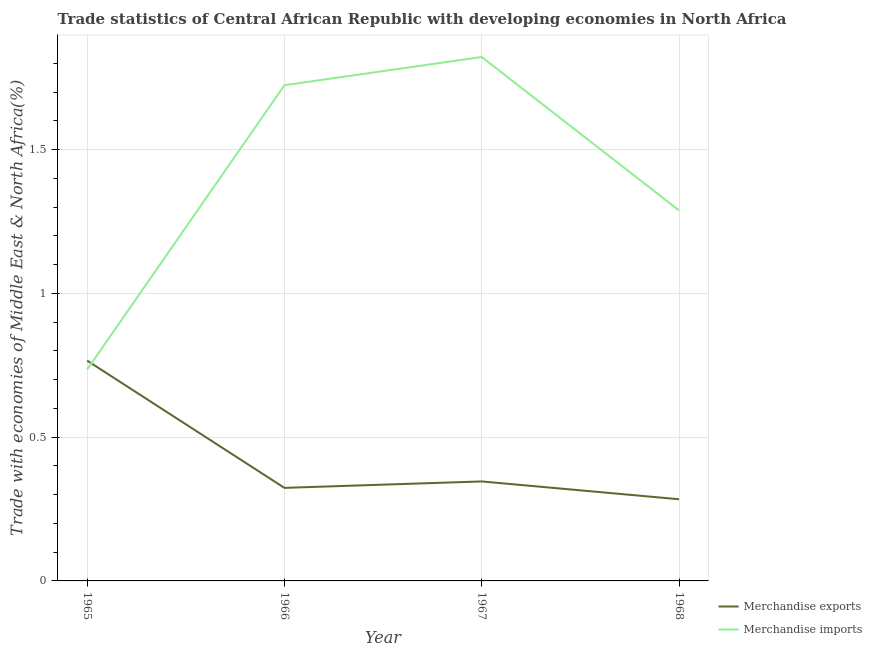What is the merchandise imports in 1965?
Give a very brief answer. 0.74. Across all years, what is the maximum merchandise imports?
Ensure brevity in your answer.  1.82. Across all years, what is the minimum merchandise exports?
Ensure brevity in your answer.  0.28. In which year was the merchandise exports maximum?
Give a very brief answer. 1965. In which year was the merchandise imports minimum?
Offer a terse response. 1965. What is the total merchandise exports in the graph?
Provide a short and direct response. 1.72. What is the difference between the merchandise imports in 1966 and that in 1968?
Give a very brief answer. 0.44. What is the difference between the merchandise exports in 1967 and the merchandise imports in 1965?
Provide a short and direct response. -0.39. What is the average merchandise imports per year?
Your answer should be compact. 1.39. In the year 1966, what is the difference between the merchandise imports and merchandise exports?
Keep it short and to the point. 1.4. What is the ratio of the merchandise imports in 1965 to that in 1966?
Offer a very short reply. 0.43. Is the merchandise imports in 1967 less than that in 1968?
Give a very brief answer. No. What is the difference between the highest and the second highest merchandise exports?
Your answer should be very brief. 0.42. What is the difference between the highest and the lowest merchandise exports?
Keep it short and to the point. 0.48. Is the merchandise exports strictly greater than the merchandise imports over the years?
Your answer should be very brief. No. How many lines are there?
Ensure brevity in your answer.  2. How many years are there in the graph?
Make the answer very short. 4. Are the values on the major ticks of Y-axis written in scientific E-notation?
Provide a succinct answer. No. Where does the legend appear in the graph?
Offer a very short reply. Bottom right. How many legend labels are there?
Ensure brevity in your answer.  2. How are the legend labels stacked?
Give a very brief answer. Vertical. What is the title of the graph?
Keep it short and to the point. Trade statistics of Central African Republic with developing economies in North Africa. Does "Domestic liabilities" appear as one of the legend labels in the graph?
Provide a short and direct response. No. What is the label or title of the X-axis?
Provide a succinct answer. Year. What is the label or title of the Y-axis?
Your response must be concise. Trade with economies of Middle East & North Africa(%). What is the Trade with economies of Middle East & North Africa(%) in Merchandise exports in 1965?
Make the answer very short. 0.77. What is the Trade with economies of Middle East & North Africa(%) in Merchandise imports in 1965?
Make the answer very short. 0.74. What is the Trade with economies of Middle East & North Africa(%) in Merchandise exports in 1966?
Offer a very short reply. 0.32. What is the Trade with economies of Middle East & North Africa(%) of Merchandise imports in 1966?
Provide a short and direct response. 1.72. What is the Trade with economies of Middle East & North Africa(%) in Merchandise exports in 1967?
Keep it short and to the point. 0.35. What is the Trade with economies of Middle East & North Africa(%) in Merchandise imports in 1967?
Keep it short and to the point. 1.82. What is the Trade with economies of Middle East & North Africa(%) in Merchandise exports in 1968?
Ensure brevity in your answer.  0.28. What is the Trade with economies of Middle East & North Africa(%) in Merchandise imports in 1968?
Make the answer very short. 1.29. Across all years, what is the maximum Trade with economies of Middle East & North Africa(%) in Merchandise exports?
Your response must be concise. 0.77. Across all years, what is the maximum Trade with economies of Middle East & North Africa(%) in Merchandise imports?
Keep it short and to the point. 1.82. Across all years, what is the minimum Trade with economies of Middle East & North Africa(%) of Merchandise exports?
Your answer should be very brief. 0.28. Across all years, what is the minimum Trade with economies of Middle East & North Africa(%) of Merchandise imports?
Offer a very short reply. 0.74. What is the total Trade with economies of Middle East & North Africa(%) in Merchandise exports in the graph?
Give a very brief answer. 1.72. What is the total Trade with economies of Middle East & North Africa(%) in Merchandise imports in the graph?
Your answer should be very brief. 5.57. What is the difference between the Trade with economies of Middle East & North Africa(%) in Merchandise exports in 1965 and that in 1966?
Your response must be concise. 0.44. What is the difference between the Trade with economies of Middle East & North Africa(%) in Merchandise imports in 1965 and that in 1966?
Offer a terse response. -0.99. What is the difference between the Trade with economies of Middle East & North Africa(%) of Merchandise exports in 1965 and that in 1967?
Give a very brief answer. 0.42. What is the difference between the Trade with economies of Middle East & North Africa(%) of Merchandise imports in 1965 and that in 1967?
Give a very brief answer. -1.09. What is the difference between the Trade with economies of Middle East & North Africa(%) of Merchandise exports in 1965 and that in 1968?
Provide a short and direct response. 0.48. What is the difference between the Trade with economies of Middle East & North Africa(%) of Merchandise imports in 1965 and that in 1968?
Ensure brevity in your answer.  -0.55. What is the difference between the Trade with economies of Middle East & North Africa(%) of Merchandise exports in 1966 and that in 1967?
Your answer should be very brief. -0.02. What is the difference between the Trade with economies of Middle East & North Africa(%) of Merchandise imports in 1966 and that in 1967?
Keep it short and to the point. -0.1. What is the difference between the Trade with economies of Middle East & North Africa(%) in Merchandise exports in 1966 and that in 1968?
Give a very brief answer. 0.04. What is the difference between the Trade with economies of Middle East & North Africa(%) in Merchandise imports in 1966 and that in 1968?
Provide a succinct answer. 0.44. What is the difference between the Trade with economies of Middle East & North Africa(%) of Merchandise exports in 1967 and that in 1968?
Provide a short and direct response. 0.06. What is the difference between the Trade with economies of Middle East & North Africa(%) in Merchandise imports in 1967 and that in 1968?
Provide a short and direct response. 0.53. What is the difference between the Trade with economies of Middle East & North Africa(%) of Merchandise exports in 1965 and the Trade with economies of Middle East & North Africa(%) of Merchandise imports in 1966?
Give a very brief answer. -0.96. What is the difference between the Trade with economies of Middle East & North Africa(%) in Merchandise exports in 1965 and the Trade with economies of Middle East & North Africa(%) in Merchandise imports in 1967?
Your answer should be very brief. -1.06. What is the difference between the Trade with economies of Middle East & North Africa(%) of Merchandise exports in 1965 and the Trade with economies of Middle East & North Africa(%) of Merchandise imports in 1968?
Provide a short and direct response. -0.52. What is the difference between the Trade with economies of Middle East & North Africa(%) of Merchandise exports in 1966 and the Trade with economies of Middle East & North Africa(%) of Merchandise imports in 1967?
Keep it short and to the point. -1.5. What is the difference between the Trade with economies of Middle East & North Africa(%) in Merchandise exports in 1966 and the Trade with economies of Middle East & North Africa(%) in Merchandise imports in 1968?
Offer a terse response. -0.96. What is the difference between the Trade with economies of Middle East & North Africa(%) of Merchandise exports in 1967 and the Trade with economies of Middle East & North Africa(%) of Merchandise imports in 1968?
Give a very brief answer. -0.94. What is the average Trade with economies of Middle East & North Africa(%) of Merchandise exports per year?
Offer a very short reply. 0.43. What is the average Trade with economies of Middle East & North Africa(%) of Merchandise imports per year?
Offer a terse response. 1.39. In the year 1965, what is the difference between the Trade with economies of Middle East & North Africa(%) of Merchandise exports and Trade with economies of Middle East & North Africa(%) of Merchandise imports?
Provide a short and direct response. 0.03. In the year 1966, what is the difference between the Trade with economies of Middle East & North Africa(%) in Merchandise exports and Trade with economies of Middle East & North Africa(%) in Merchandise imports?
Offer a very short reply. -1.4. In the year 1967, what is the difference between the Trade with economies of Middle East & North Africa(%) in Merchandise exports and Trade with economies of Middle East & North Africa(%) in Merchandise imports?
Your answer should be compact. -1.48. In the year 1968, what is the difference between the Trade with economies of Middle East & North Africa(%) of Merchandise exports and Trade with economies of Middle East & North Africa(%) of Merchandise imports?
Your answer should be compact. -1. What is the ratio of the Trade with economies of Middle East & North Africa(%) of Merchandise exports in 1965 to that in 1966?
Offer a very short reply. 2.37. What is the ratio of the Trade with economies of Middle East & North Africa(%) in Merchandise imports in 1965 to that in 1966?
Offer a very short reply. 0.43. What is the ratio of the Trade with economies of Middle East & North Africa(%) in Merchandise exports in 1965 to that in 1967?
Provide a short and direct response. 2.21. What is the ratio of the Trade with economies of Middle East & North Africa(%) of Merchandise imports in 1965 to that in 1967?
Keep it short and to the point. 0.4. What is the ratio of the Trade with economies of Middle East & North Africa(%) of Merchandise exports in 1965 to that in 1968?
Provide a succinct answer. 2.7. What is the ratio of the Trade with economies of Middle East & North Africa(%) in Merchandise imports in 1965 to that in 1968?
Make the answer very short. 0.57. What is the ratio of the Trade with economies of Middle East & North Africa(%) of Merchandise exports in 1966 to that in 1967?
Ensure brevity in your answer.  0.94. What is the ratio of the Trade with economies of Middle East & North Africa(%) in Merchandise imports in 1966 to that in 1967?
Ensure brevity in your answer.  0.95. What is the ratio of the Trade with economies of Middle East & North Africa(%) in Merchandise exports in 1966 to that in 1968?
Your response must be concise. 1.14. What is the ratio of the Trade with economies of Middle East & North Africa(%) in Merchandise imports in 1966 to that in 1968?
Provide a succinct answer. 1.34. What is the ratio of the Trade with economies of Middle East & North Africa(%) in Merchandise exports in 1967 to that in 1968?
Ensure brevity in your answer.  1.22. What is the ratio of the Trade with economies of Middle East & North Africa(%) of Merchandise imports in 1967 to that in 1968?
Provide a succinct answer. 1.41. What is the difference between the highest and the second highest Trade with economies of Middle East & North Africa(%) in Merchandise exports?
Keep it short and to the point. 0.42. What is the difference between the highest and the second highest Trade with economies of Middle East & North Africa(%) in Merchandise imports?
Provide a short and direct response. 0.1. What is the difference between the highest and the lowest Trade with economies of Middle East & North Africa(%) of Merchandise exports?
Keep it short and to the point. 0.48. What is the difference between the highest and the lowest Trade with economies of Middle East & North Africa(%) in Merchandise imports?
Ensure brevity in your answer.  1.09. 